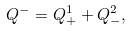<formula> <loc_0><loc_0><loc_500><loc_500>Q ^ { - } = Q ^ { 1 } _ { + } + Q ^ { 2 } _ { - } ,</formula> 